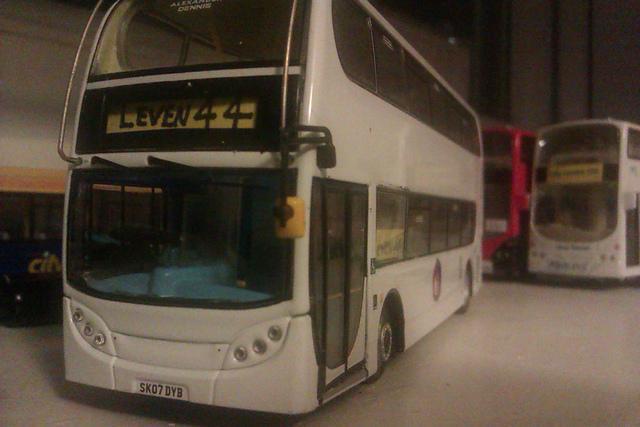How many vehicles are pictured?
Give a very brief answer. 3. How many buses are there?
Give a very brief answer. 3. 